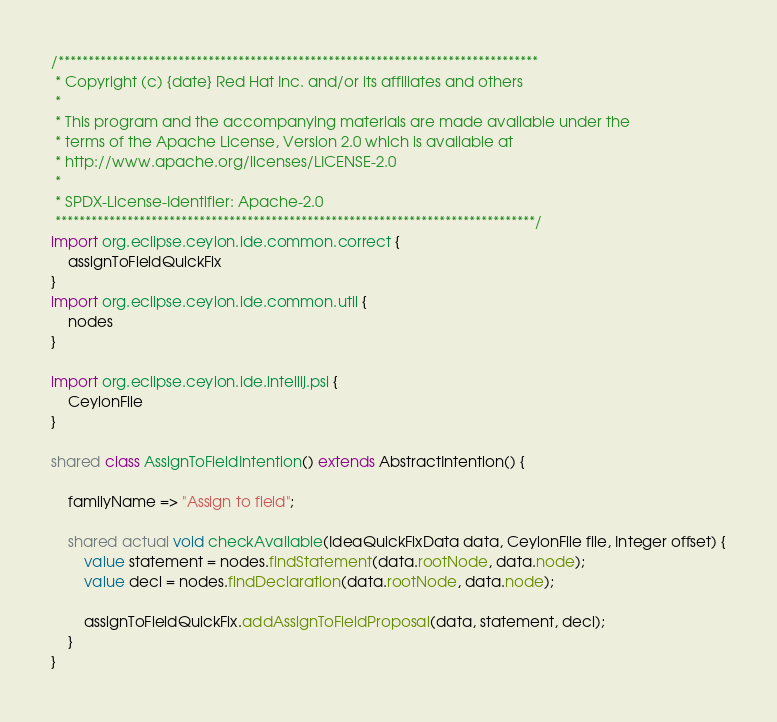<code> <loc_0><loc_0><loc_500><loc_500><_Ceylon_>/********************************************************************************
 * Copyright (c) {date} Red Hat Inc. and/or its affiliates and others
 *
 * This program and the accompanying materials are made available under the 
 * terms of the Apache License, Version 2.0 which is available at
 * http://www.apache.org/licenses/LICENSE-2.0
 *
 * SPDX-License-Identifier: Apache-2.0 
 ********************************************************************************/
import org.eclipse.ceylon.ide.common.correct {
    assignToFieldQuickFix
}
import org.eclipse.ceylon.ide.common.util {
    nodes
}

import org.eclipse.ceylon.ide.intellij.psi {
    CeylonFile
}

shared class AssignToFieldIntention() extends AbstractIntention() {
    
    familyName => "Assign to field";
    
    shared actual void checkAvailable(IdeaQuickFixData data, CeylonFile file, Integer offset) {
        value statement = nodes.findStatement(data.rootNode, data.node);
        value decl = nodes.findDeclaration(data.rootNode, data.node);

        assignToFieldQuickFix.addAssignToFieldProposal(data, statement, decl);
    }
}</code> 